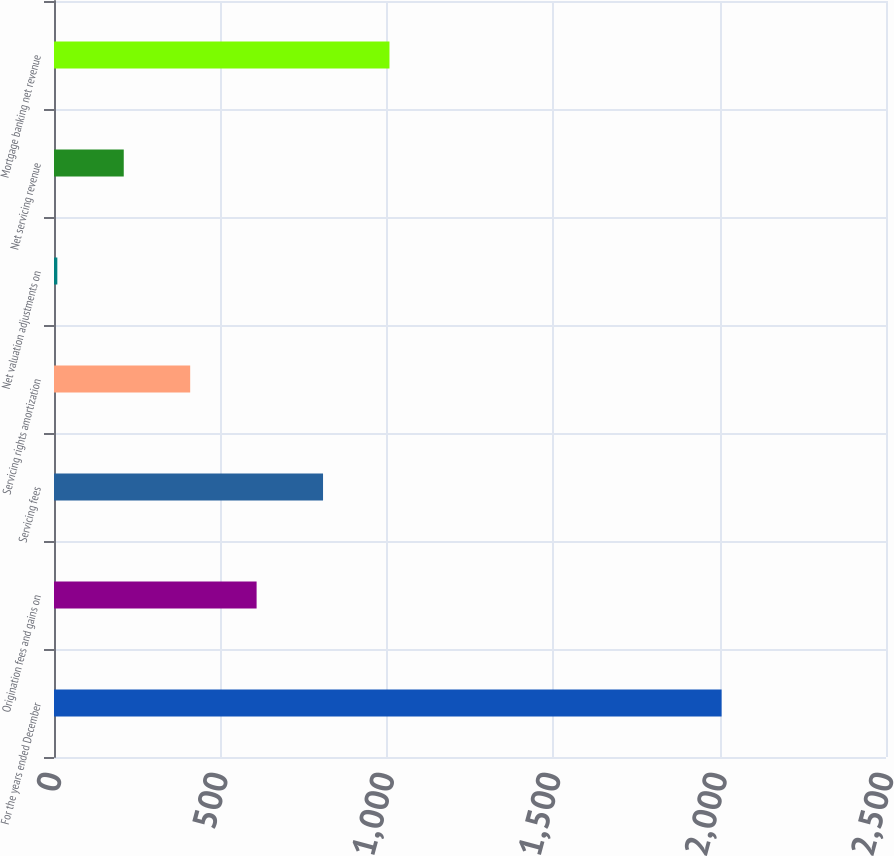Convert chart. <chart><loc_0><loc_0><loc_500><loc_500><bar_chart><fcel>For the years ended December<fcel>Origination fees and gains on<fcel>Servicing fees<fcel>Servicing rights amortization<fcel>Net valuation adjustments on<fcel>Net servicing revenue<fcel>Mortgage banking net revenue<nl><fcel>2006<fcel>608.8<fcel>808.4<fcel>409.2<fcel>10<fcel>209.6<fcel>1008<nl></chart> 